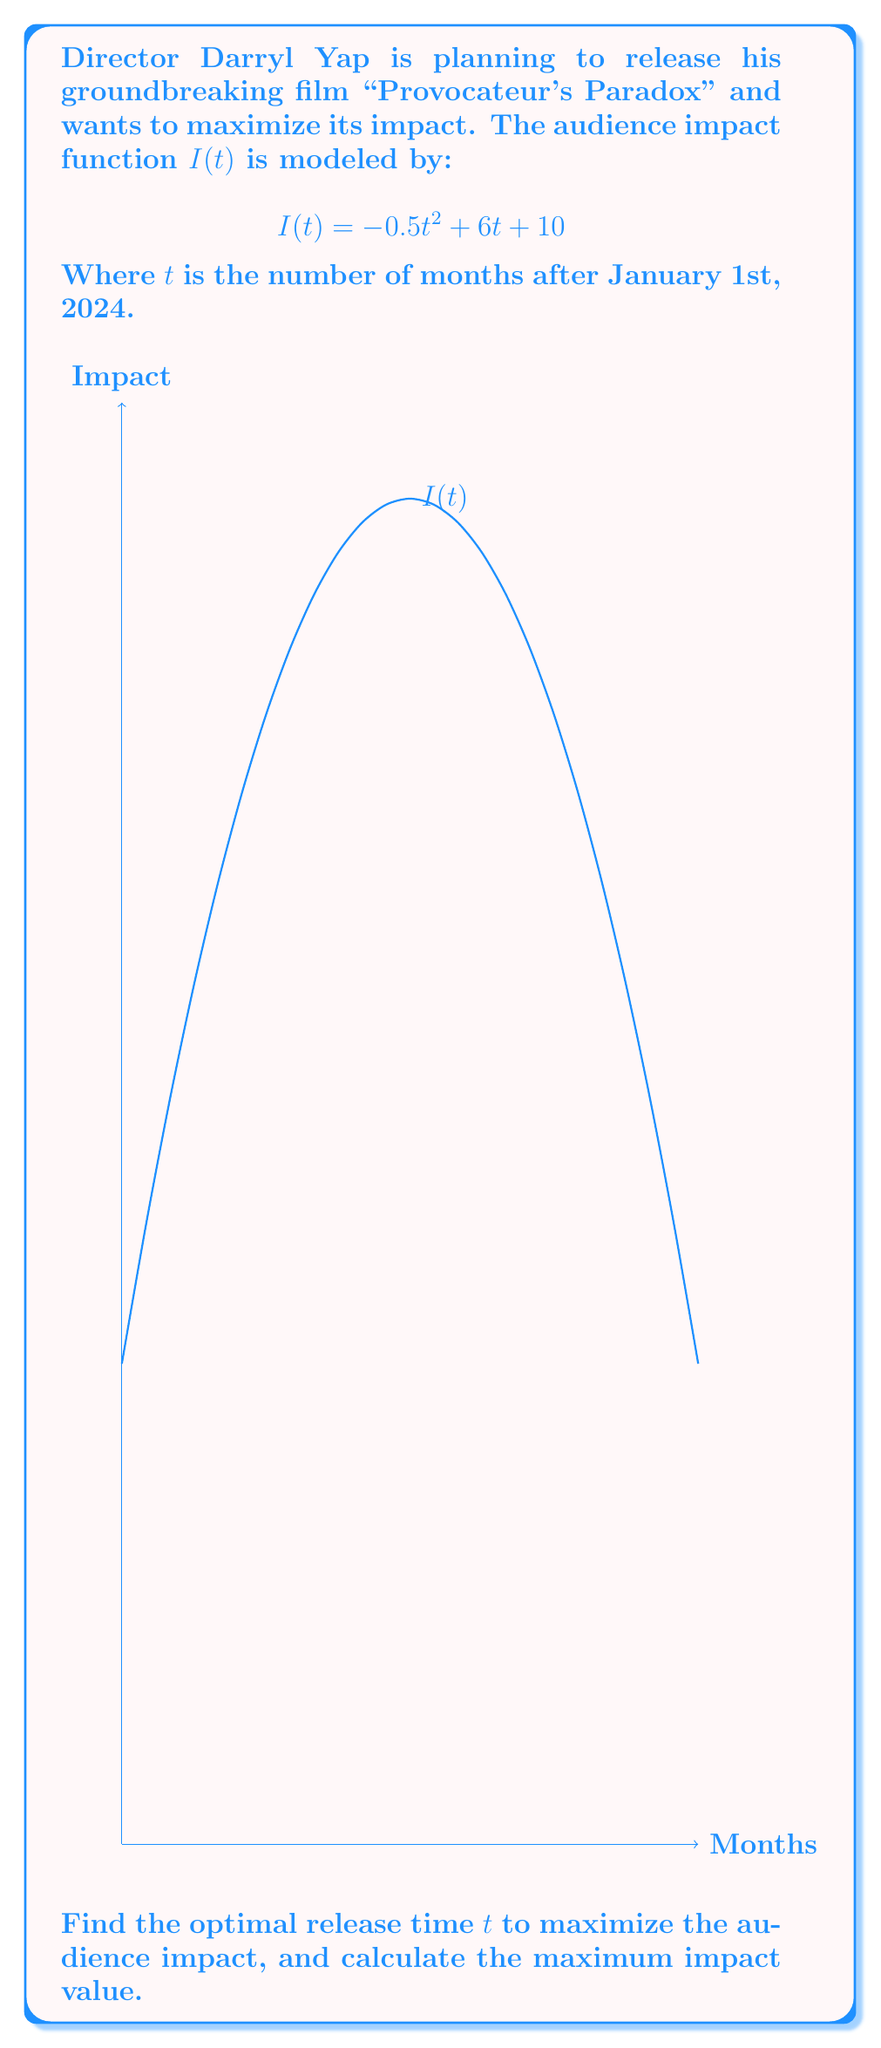Could you help me with this problem? To find the optimal release time and maximum impact, we need to find the maximum of the function $I(t)$. This can be done using differential calculus:

1) First, find the derivative of $I(t)$:
   $$I'(t) = \frac{d}{dt}(-0.5t^2 + 6t + 10) = -t + 6$$

2) To find the maximum, set $I'(t) = 0$ and solve for $t$:
   $$-t + 6 = 0$$
   $$t = 6$$

3) Verify this is a maximum by checking the second derivative:
   $$I''(t) = -1 < 0$$, confirming it's a maximum.

4) Calculate the maximum impact by plugging $t = 6$ into the original function:
   $$I(6) = -0.5(6)^2 + 6(6) + 10$$
   $$= -18 + 36 + 10 = 28$$

Therefore, the optimal release time is 6 months after January 1st, 2024 (i.e., July 1st, 2024), and the maximum impact value is 28.
Answer: Optimal release: 6 months after Jan 1, 2024; Maximum impact: 28 